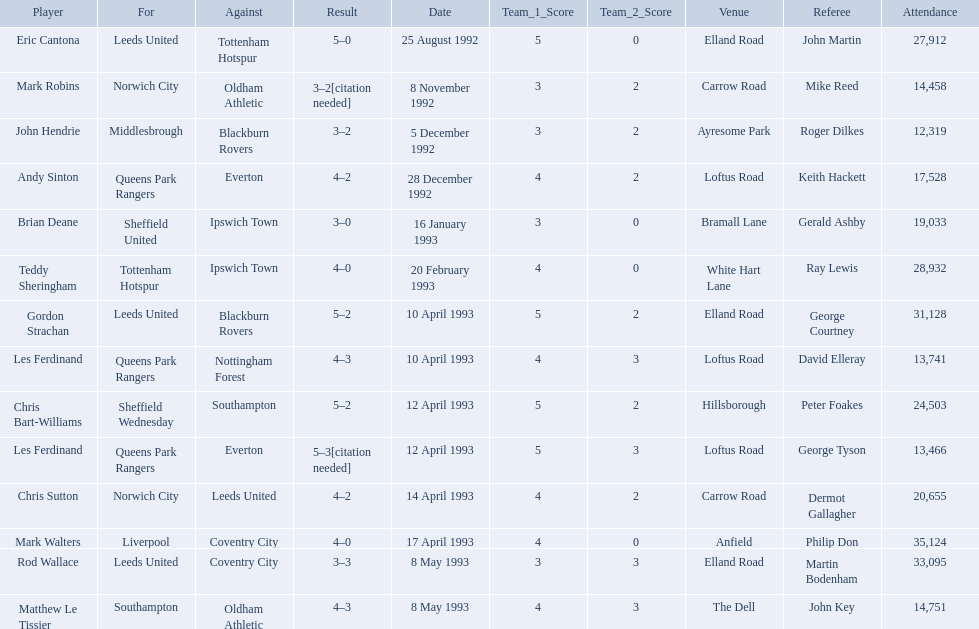Who are all the players? Eric Cantona, Mark Robins, John Hendrie, Andy Sinton, Brian Deane, Teddy Sheringham, Gordon Strachan, Les Ferdinand, Chris Bart-Williams, Les Ferdinand, Chris Sutton, Mark Walters, Rod Wallace, Matthew Le Tissier. What were their results? 5–0, 3–2[citation needed], 3–2, 4–2, 3–0, 4–0, 5–2, 4–3, 5–2, 5–3[citation needed], 4–2, 4–0, 3–3, 4–3. Which player tied with mark robins? John Hendrie. 